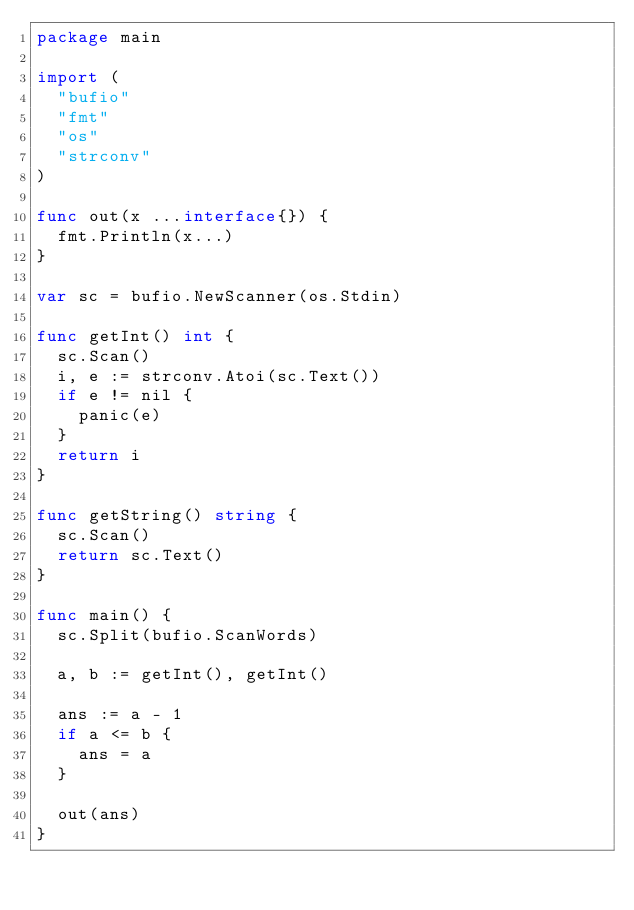<code> <loc_0><loc_0><loc_500><loc_500><_Go_>package main

import (
	"bufio"
	"fmt"
	"os"
	"strconv"
)

func out(x ...interface{}) {
	fmt.Println(x...)
}

var sc = bufio.NewScanner(os.Stdin)

func getInt() int {
	sc.Scan()
	i, e := strconv.Atoi(sc.Text())
	if e != nil {
		panic(e)
	}
	return i
}

func getString() string {
	sc.Scan()
	return sc.Text()
}

func main() {
	sc.Split(bufio.ScanWords)

	a, b := getInt(), getInt()

	ans := a - 1
	if a <= b {
		ans = a
	}

	out(ans)
}
</code> 